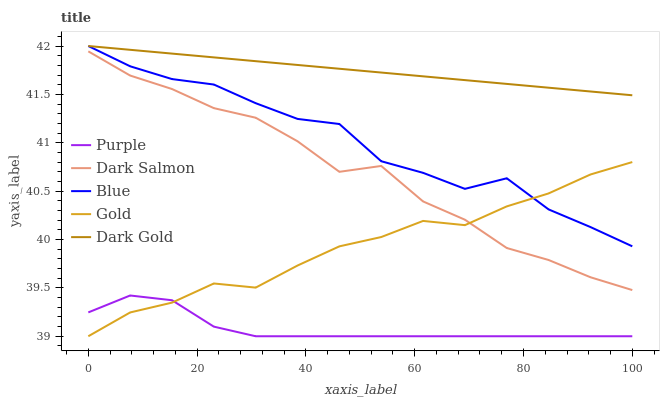Does Purple have the minimum area under the curve?
Answer yes or no. Yes. Does Dark Gold have the maximum area under the curve?
Answer yes or no. Yes. Does Blue have the minimum area under the curve?
Answer yes or no. No. Does Blue have the maximum area under the curve?
Answer yes or no. No. Is Dark Gold the smoothest?
Answer yes or no. Yes. Is Blue the roughest?
Answer yes or no. Yes. Is Dark Salmon the smoothest?
Answer yes or no. No. Is Dark Salmon the roughest?
Answer yes or no. No. Does Purple have the lowest value?
Answer yes or no. Yes. Does Blue have the lowest value?
Answer yes or no. No. Does Dark Gold have the highest value?
Answer yes or no. Yes. Does Dark Salmon have the highest value?
Answer yes or no. No. Is Purple less than Dark Salmon?
Answer yes or no. Yes. Is Dark Gold greater than Dark Salmon?
Answer yes or no. Yes. Does Dark Salmon intersect Gold?
Answer yes or no. Yes. Is Dark Salmon less than Gold?
Answer yes or no. No. Is Dark Salmon greater than Gold?
Answer yes or no. No. Does Purple intersect Dark Salmon?
Answer yes or no. No. 